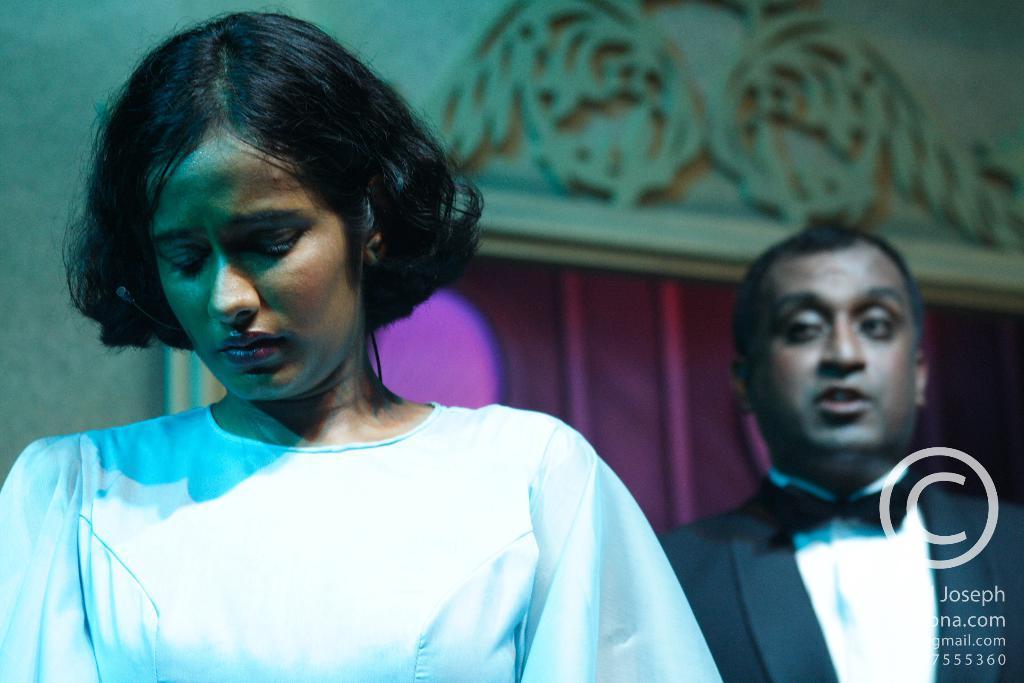In one or two sentences, can you explain what this image depicts? In the image in the center, we can see two persons are standing. In the bottom right side of the image, there is a watermark. In the background there is a wall and a curtain. 